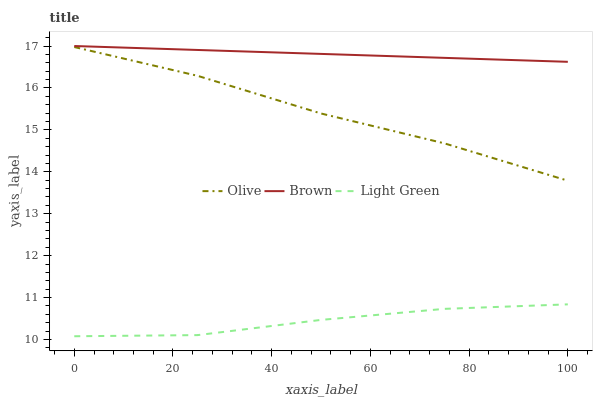Does Brown have the minimum area under the curve?
Answer yes or no. No. Does Light Green have the maximum area under the curve?
Answer yes or no. No. Is Light Green the smoothest?
Answer yes or no. No. Is Brown the roughest?
Answer yes or no. No. Does Brown have the lowest value?
Answer yes or no. No. Does Light Green have the highest value?
Answer yes or no. No. Is Olive less than Brown?
Answer yes or no. Yes. Is Brown greater than Olive?
Answer yes or no. Yes. Does Olive intersect Brown?
Answer yes or no. No. 